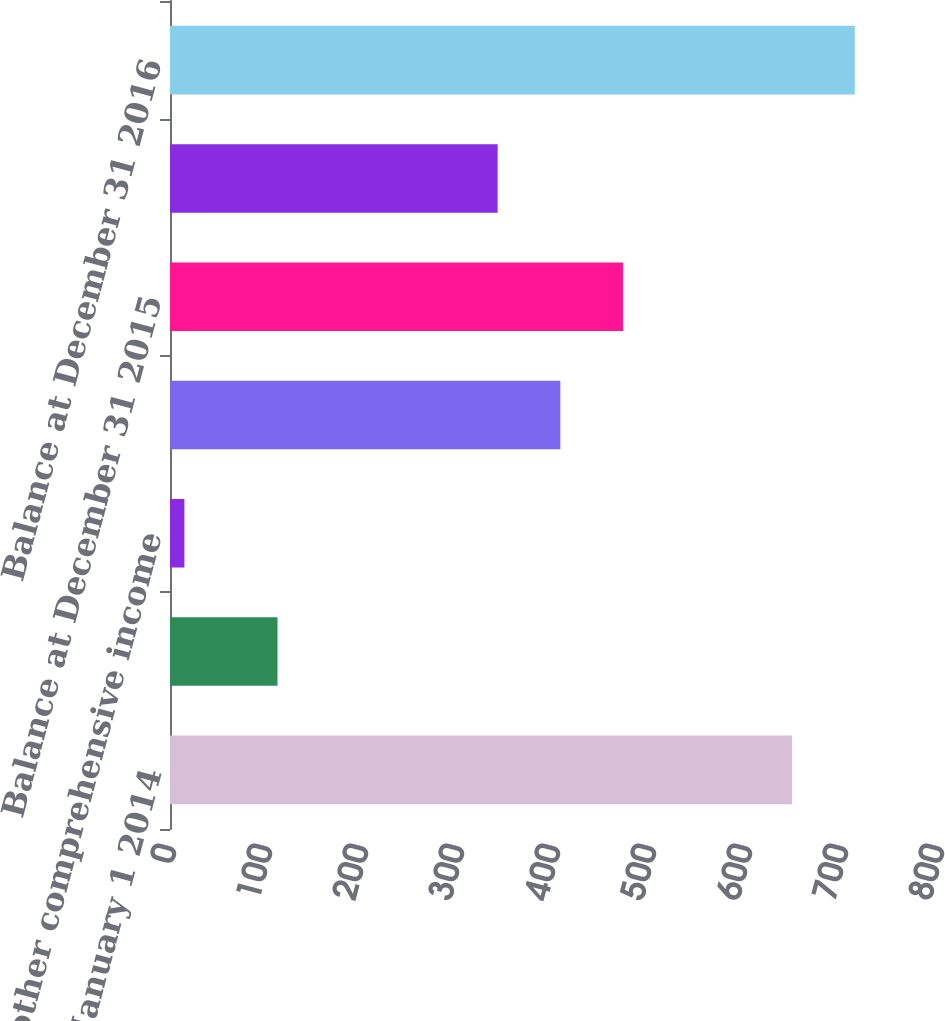Convert chart to OTSL. <chart><loc_0><loc_0><loc_500><loc_500><bar_chart><fcel>Balance at January 1 2014<fcel>Amounts reclassified from<fcel>Net other comprehensive income<fcel>Balance at December 31 2014<fcel>Balance at December 31 2015<fcel>Net other comprehensive loss<fcel>Balance at December 31 2016<nl><fcel>648<fcel>112<fcel>15<fcel>406.6<fcel>471.9<fcel>341.3<fcel>713.3<nl></chart> 